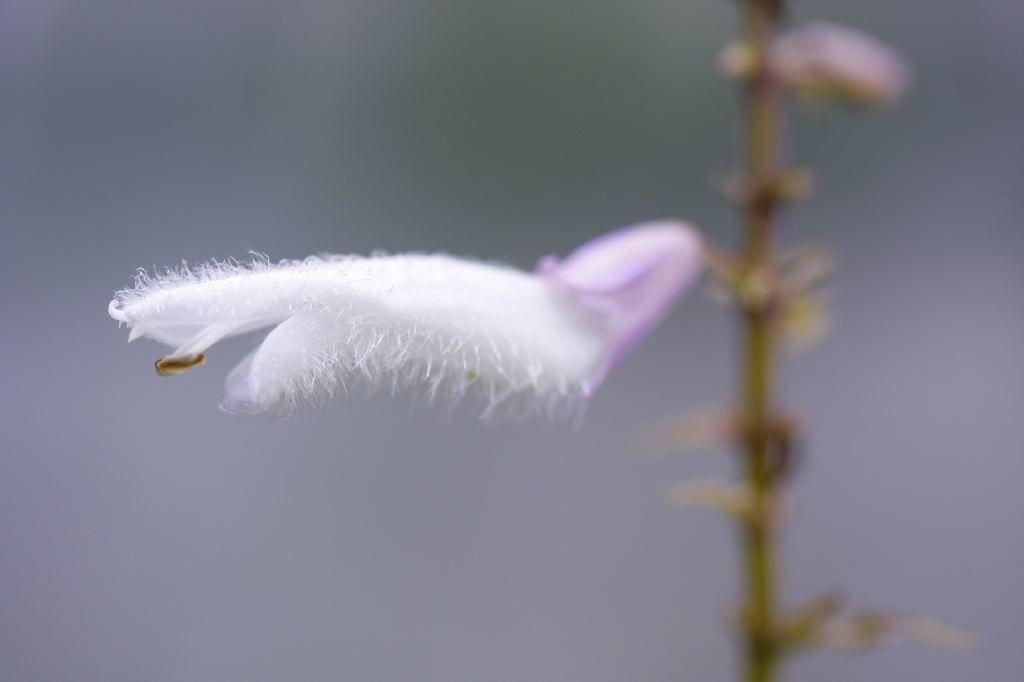What is the main subject of the image? There is a flower in the image. Can you describe the colors of the flower? The flower has white and blue colors. What part of the flower connects it to the plant? There is a stem associated with the flower. What color is the background of the image? The background of the image is white. Can you tell me how many snakes are slithering in the background of the image? There are no snakes present in the image; the background is white. What type of books can be seen in the library depicted in the image? There is no library depicted in the image; it features a flower with a white background. 